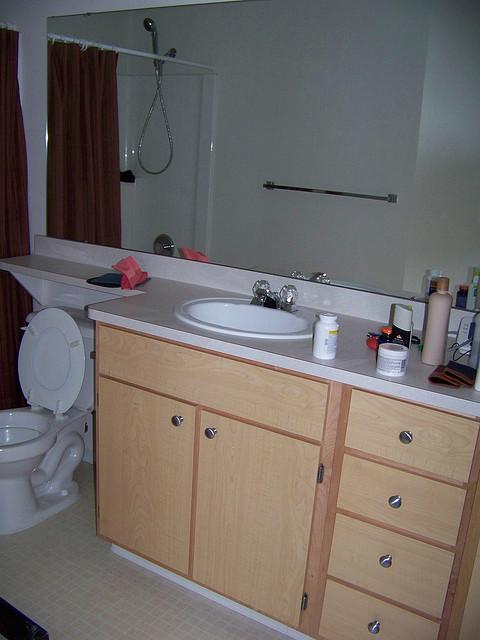What room is the woman in?
Concise answer only. Bathroom. What room is presented?
Short answer required. Bathroom. Is the counter cluttered?
Write a very short answer. Yes. Is there a vent under the cabinets?
Keep it brief. No. What is plugged into the outlet?
Short answer required. Nothing. How many drawers are there?
Give a very brief answer. 4. What is shown in the mirror?
Give a very brief answer. Shower. Where is the toilet paper?
Concise answer only. Next to toilet. What color is the toilet?
Keep it brief. White. What is the sink made out of?
Write a very short answer. Porcelain. 